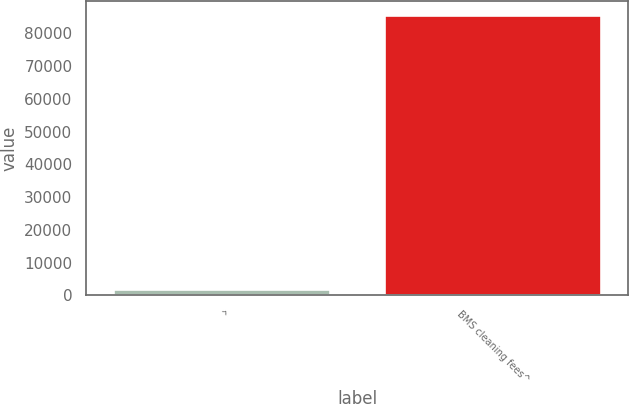Convert chart. <chart><loc_0><loc_0><loc_500><loc_500><bar_chart><fcel>^<fcel>BMS cleaning fees^<nl><fcel>2014<fcel>85658<nl></chart> 